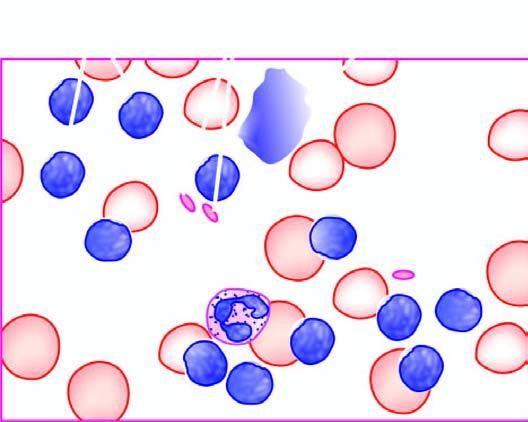what is some degenerated forms appearing as?
Answer the question using a single word or phrase. Bare smudged nuclei 